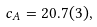<formula> <loc_0><loc_0><loc_500><loc_500>c _ { A } = 2 0 . 7 ( 3 ) ,</formula> 